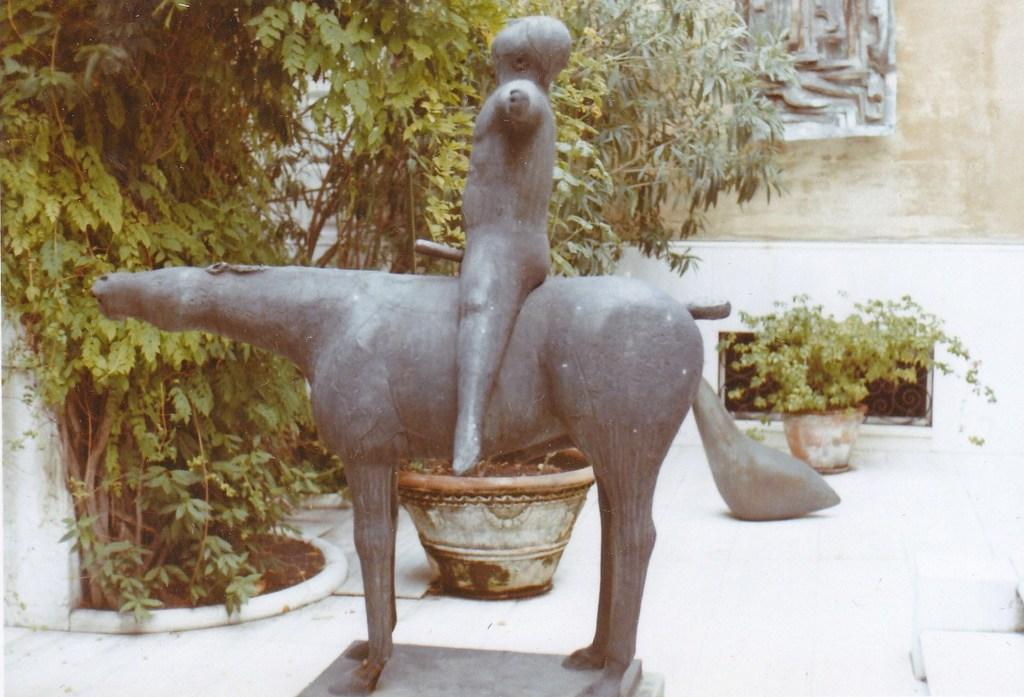What is happening in the main scene of the image? There is a depiction of a person sitting on an animal in the image. What can be seen in the distance behind the main scene? There are trees and plant pots in the background of the image. What is on the wall in the background of the image? There is a structure on the wall in the background of the image. How many snakes are crawling on the person's shoes in the image? There are no snakes or shoes present in the image. What type of plant is growing in the plant pots in the image? The image does not provide enough detail to determine the type of plant growing in the plant pots. 